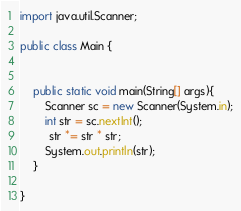<code> <loc_0><loc_0><loc_500><loc_500><_Java_>import java.util.Scanner;

public class Main {


    public static void main(String[] args){
    	Scanner sc = new Scanner(System.in);
    	int str = sc.nextInt();
    	 str *= str * str;
        System.out.println(str);
    }

}</code> 